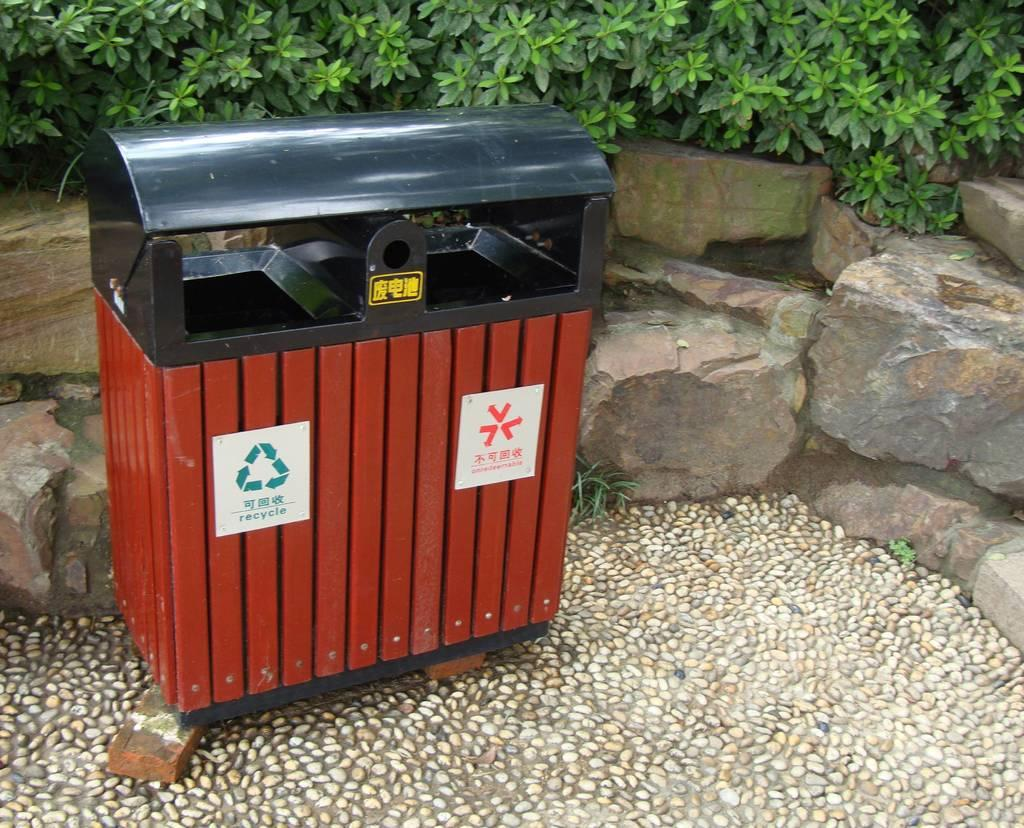Provide a one-sentence caption for the provided image. A waste container that has a bin for recycle, and a bin for trash attached to it. 